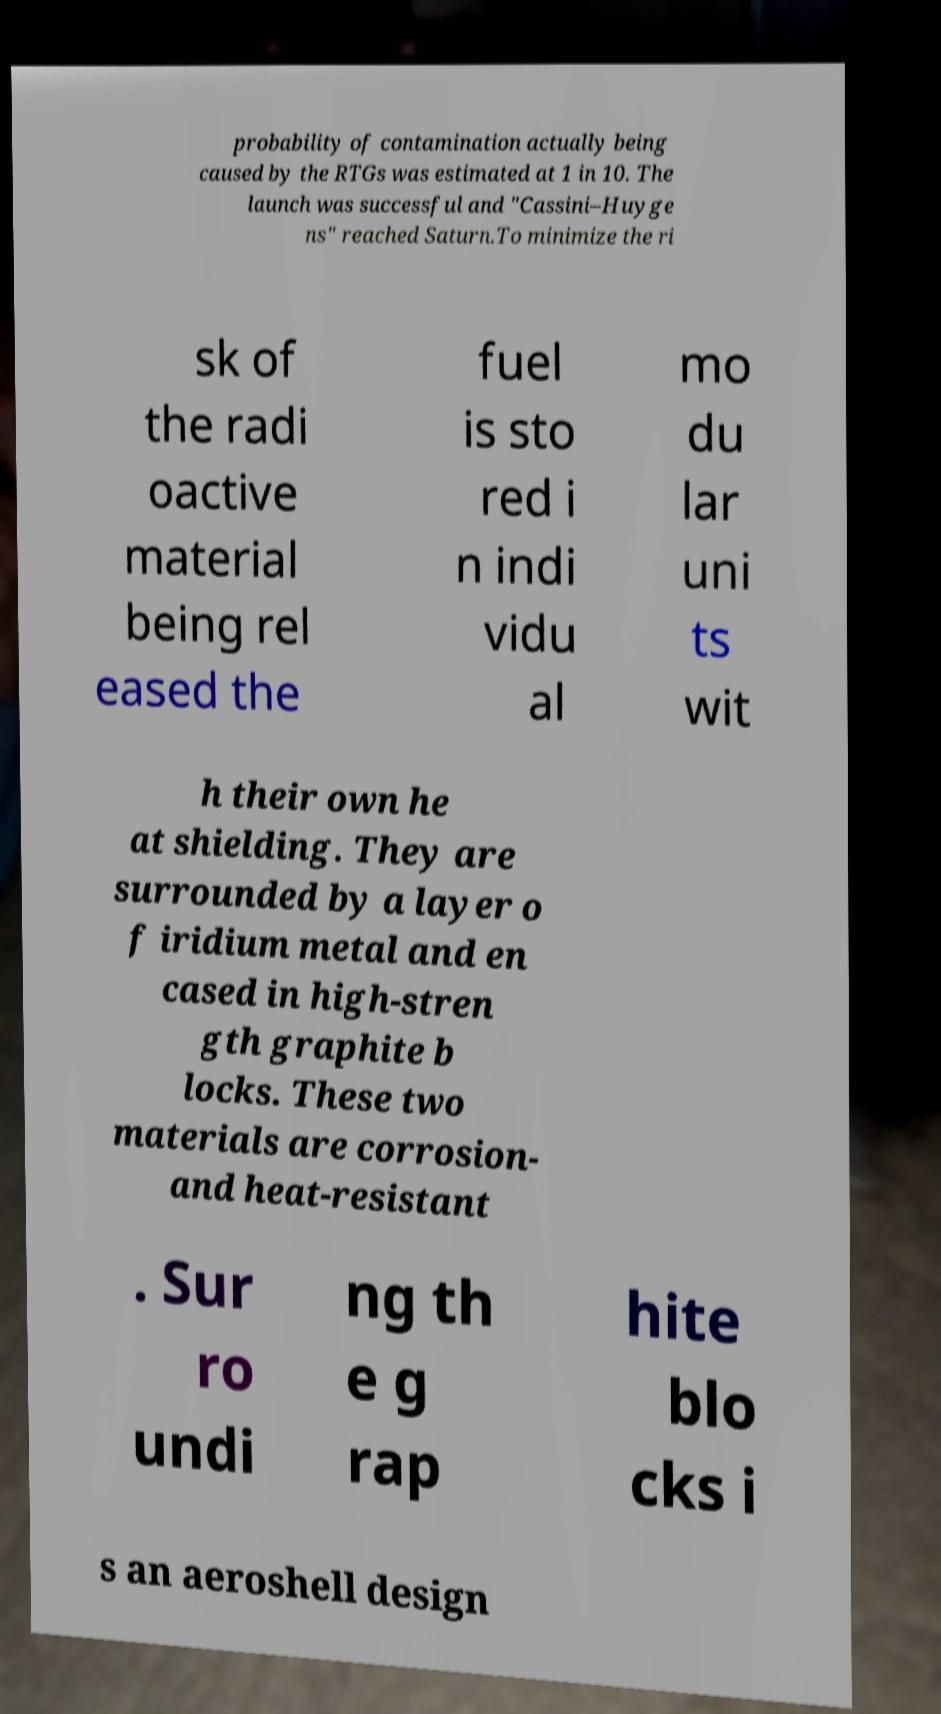I need the written content from this picture converted into text. Can you do that? probability of contamination actually being caused by the RTGs was estimated at 1 in 10. The launch was successful and "Cassini–Huyge ns" reached Saturn.To minimize the ri sk of the radi oactive material being rel eased the fuel is sto red i n indi vidu al mo du lar uni ts wit h their own he at shielding. They are surrounded by a layer o f iridium metal and en cased in high-stren gth graphite b locks. These two materials are corrosion- and heat-resistant . Sur ro undi ng th e g rap hite blo cks i s an aeroshell design 